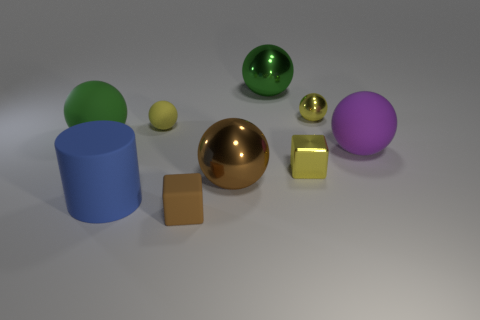Is there any other thing that has the same shape as the large blue rubber object?
Give a very brief answer. No. The big shiny ball in front of the yellow block is what color?
Your response must be concise. Brown. What shape is the small object that is left of the tiny yellow metal block and behind the tiny brown thing?
Offer a very short reply. Sphere. What number of other small yellow objects have the same shape as the tiny yellow matte thing?
Offer a terse response. 1. How many big green cubes are there?
Give a very brief answer. 0. What size is the sphere that is right of the big blue matte cylinder and to the left of the large brown metallic object?
Offer a very short reply. Small. What is the shape of the brown object that is the same size as the metal block?
Keep it short and to the point. Cube. Is there a large object behind the small thing that is to the right of the tiny metallic block?
Keep it short and to the point. Yes. What color is the tiny metal thing that is the same shape as the yellow matte object?
Provide a succinct answer. Yellow. Is the color of the metallic sphere to the right of the tiny yellow cube the same as the shiny block?
Give a very brief answer. Yes. 